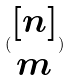Convert formula to latex. <formula><loc_0><loc_0><loc_500><loc_500>( \begin{matrix} [ n ] \\ m \end{matrix} )</formula> 